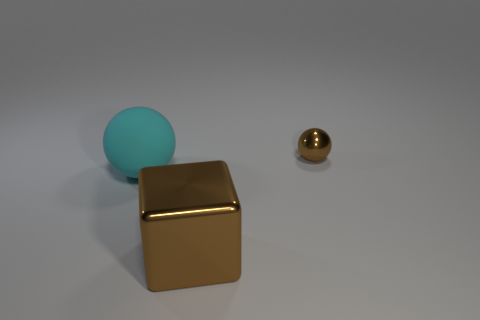Is there any other thing that is the same shape as the big brown metal object?
Provide a short and direct response. No. How many objects are either metal things or brown objects that are on the left side of the small brown ball?
Provide a succinct answer. 2. There is a cyan rubber object that is the same shape as the small metallic thing; what size is it?
Your response must be concise. Large. Are there any other things that are the same size as the brown shiny ball?
Make the answer very short. No. Are there any cubes on the left side of the shiny ball?
Ensure brevity in your answer.  Yes. Is the color of the metallic thing that is left of the small brown metallic ball the same as the metallic thing on the right side of the big cube?
Provide a succinct answer. Yes. Are there any small brown metal things that have the same shape as the big cyan rubber thing?
Make the answer very short. Yes. What number of other objects are the same color as the big shiny block?
Offer a very short reply. 1. There is a large object behind the large object that is in front of the sphere that is in front of the small sphere; what is its color?
Offer a terse response. Cyan. Are there an equal number of tiny shiny things that are left of the block and brown objects?
Offer a very short reply. No. 